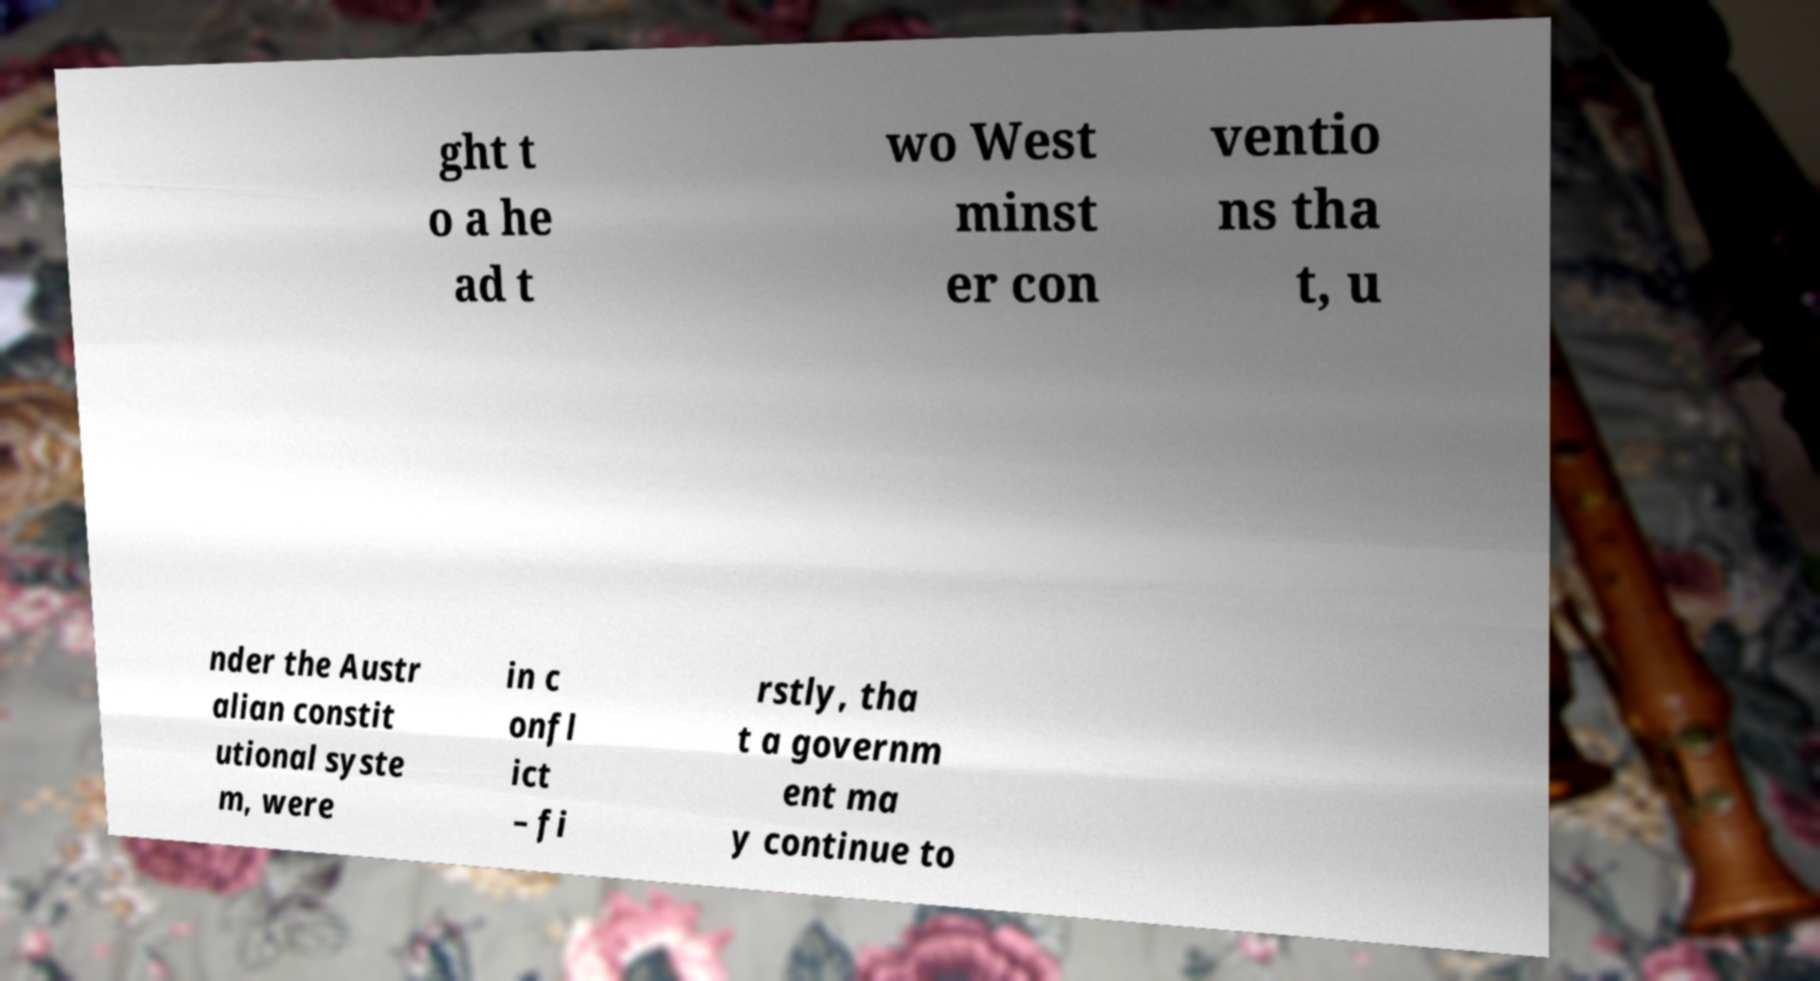I need the written content from this picture converted into text. Can you do that? ght t o a he ad t wo West minst er con ventio ns tha t, u nder the Austr alian constit utional syste m, were in c onfl ict – fi rstly, tha t a governm ent ma y continue to 